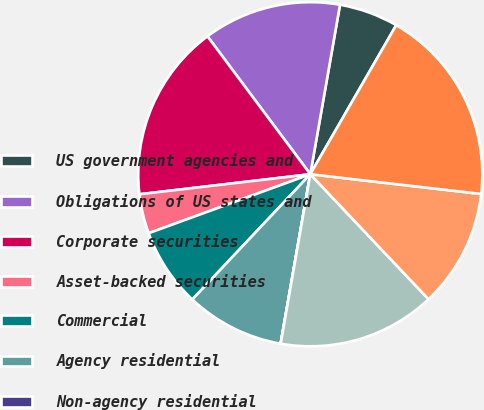Convert chart. <chart><loc_0><loc_0><loc_500><loc_500><pie_chart><fcel>US government agencies and<fcel>Obligations of US states and<fcel>Corporate securities<fcel>Asset-backed securities<fcel>Commercial<fcel>Agency residential<fcel>Non-agency residential<fcel>Foreign government securities<fcel>Foreign corporate securities<fcel>Total fixed maturity<nl><fcel>5.56%<fcel>12.96%<fcel>16.66%<fcel>3.71%<fcel>7.41%<fcel>9.26%<fcel>0.01%<fcel>14.81%<fcel>11.11%<fcel>18.51%<nl></chart> 